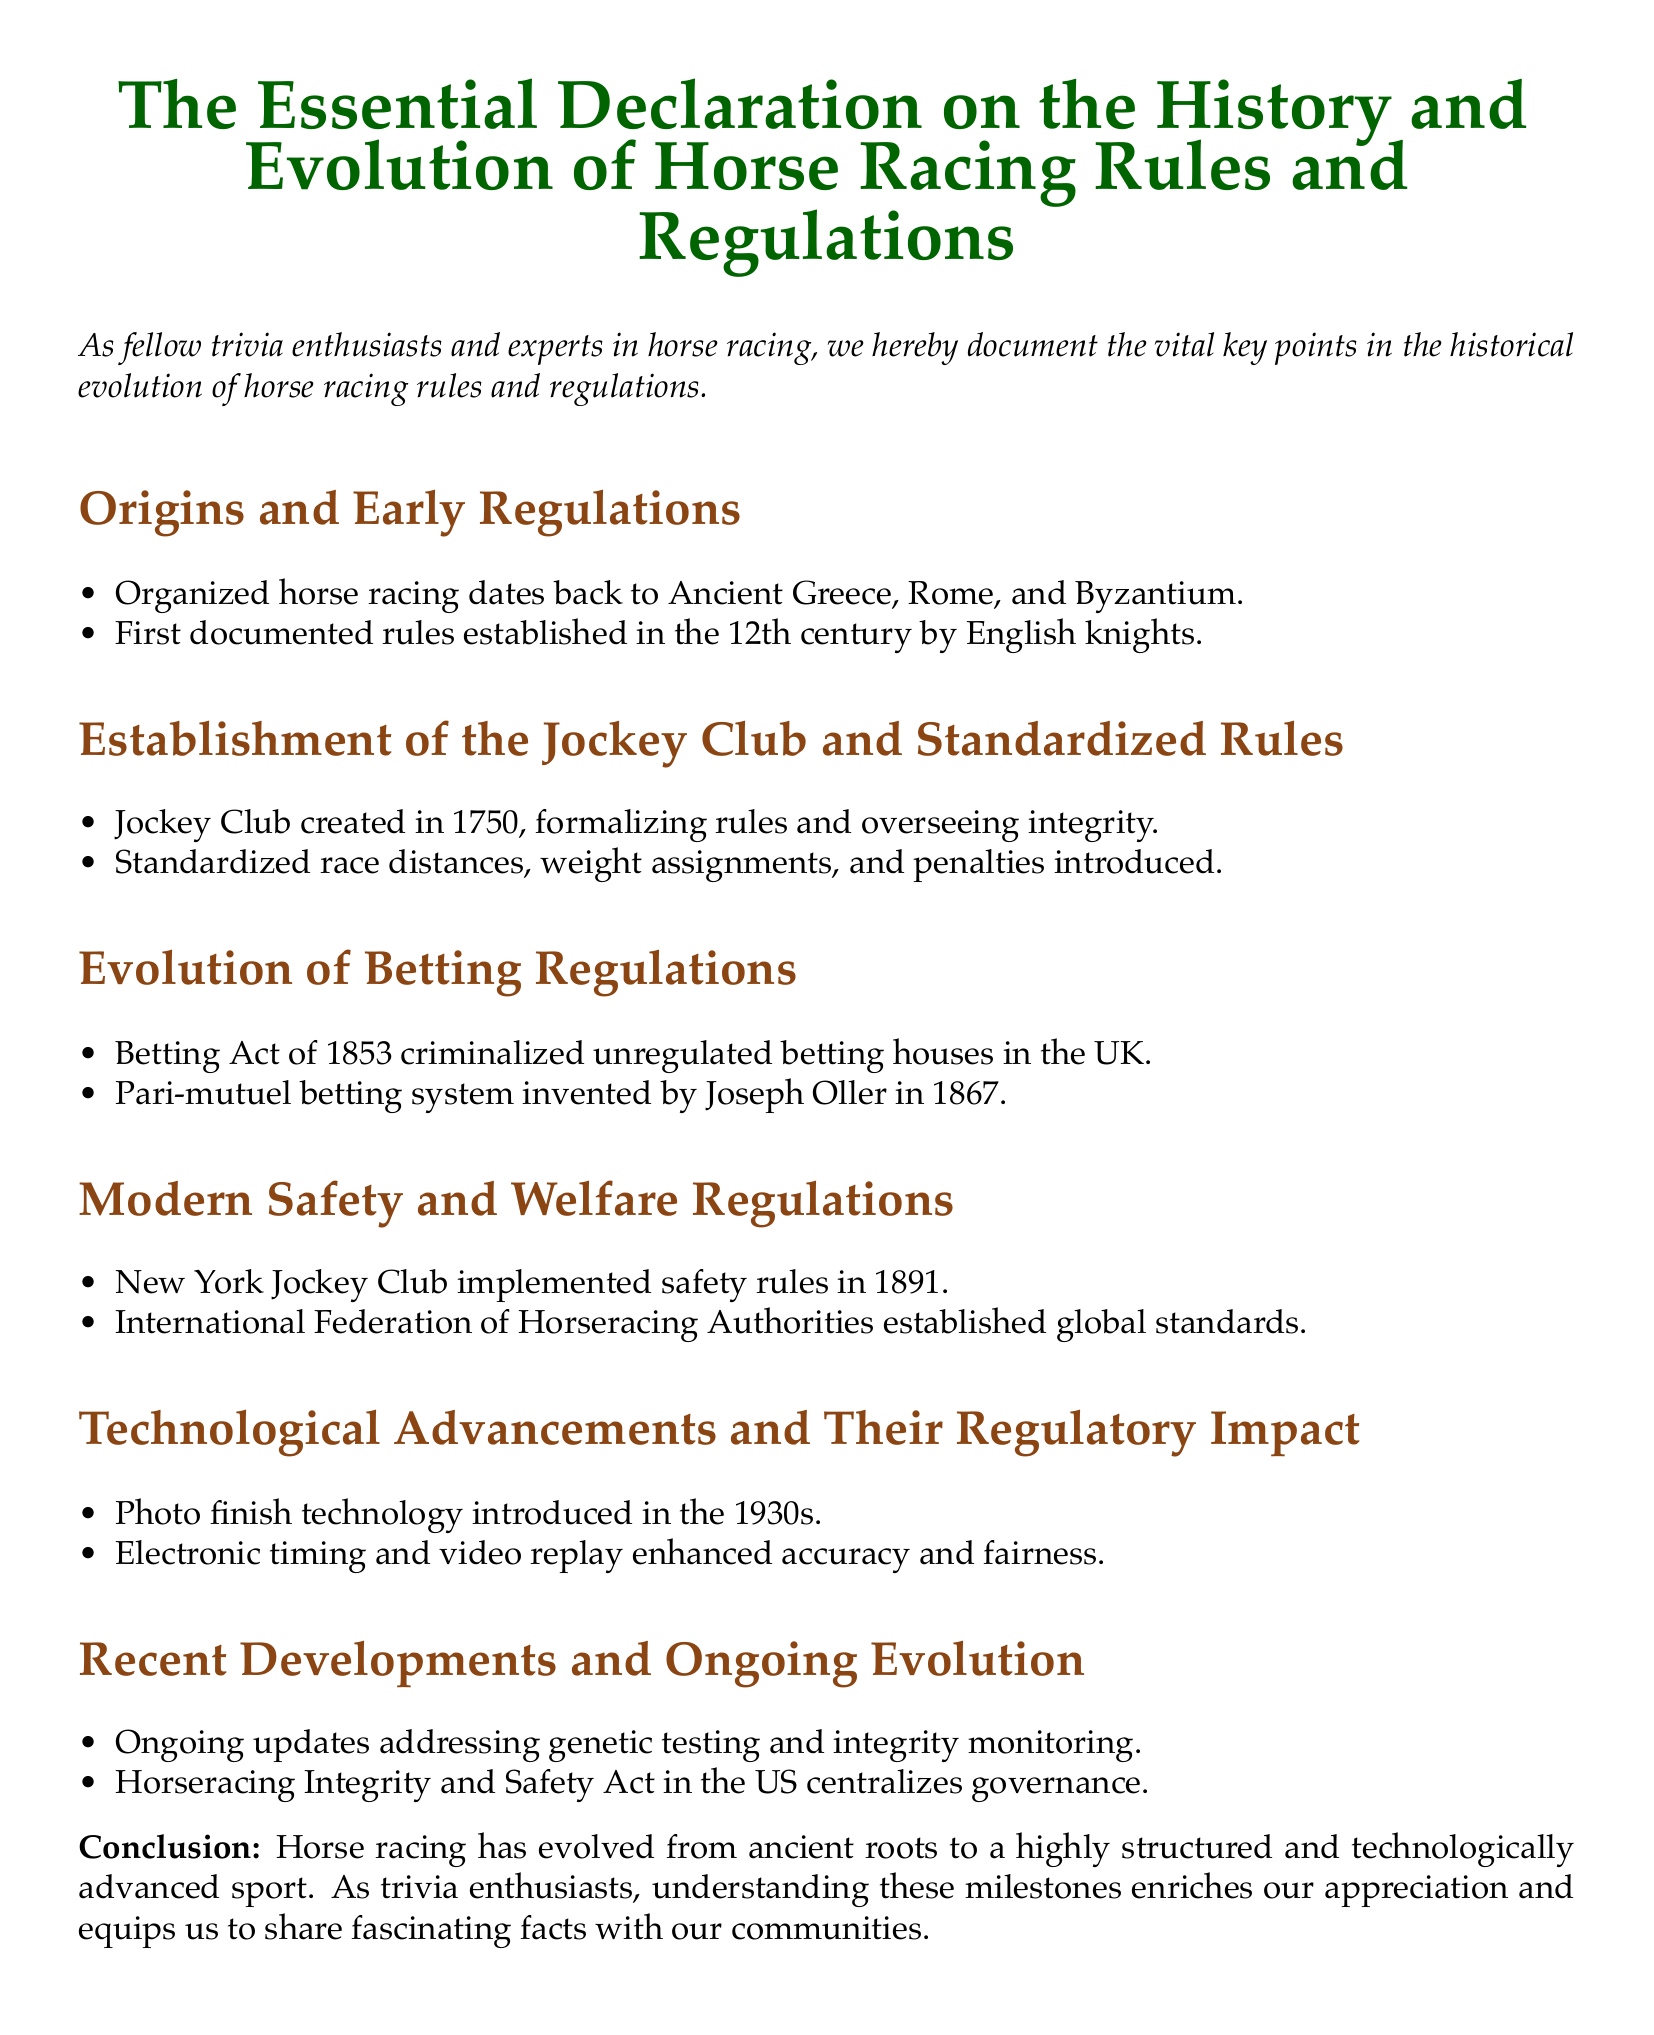What civilization is credited with the origins of organized horse racing? Organized horse racing dates back to Ancient Greece, Rome, and Byzantium.
Answer: Ancient Greece, Rome, and Byzantium In what year was the Jockey Club created? The Jockey Club was created in 1750.
Answer: 1750 What betting system was invented by Joseph Oller? The document mentions that the Pari-mutuel betting system was invented by Joseph Oller in 1867.
Answer: Pari-mutuel betting system In what year did the New York Jockey Club implement safety rules? The New York Jockey Club implemented safety rules in 1891.
Answer: 1891 What technological advancement was introduced in the 1930s? Photo finish technology was introduced in the 1930s.
Answer: Photo finish technology What act centralizes governance in horse racing in the US? The Horseracing Integrity and Safety Act in the US centralizes governance.
Answer: Horseracing Integrity and Safety Act What were the first documented rules established? The first documented rules were established in the 12th century by English knights.
Answer: 12th century What global organization established standards for horse racing? The International Federation of Horseracing Authorities established global standards.
Answer: International Federation of Horseracing Authorities What ongoing updates does the document mention related to integrity monitoring? The ongoing updates address genetic testing and integrity monitoring.
Answer: Genetic testing and integrity monitoring 